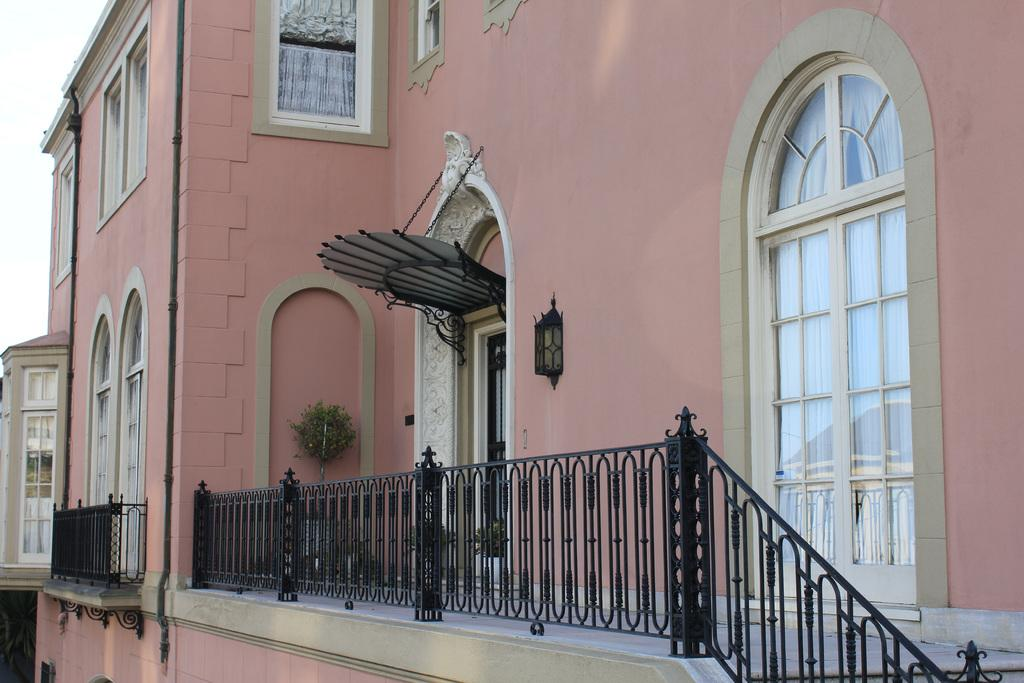What type of structure is present in the image? There is a building in the image. What feature can be seen on the building? Railings are visible in the image. Are there any plants in the image? Yes, there is a houseplant in the image. What can be seen in the background of the image? The sky is visible in the background of the image. What allows light to enter the building? There are windows in the image. What type of cap is the stove wearing in the image? There is no stove or cap present in the image. 